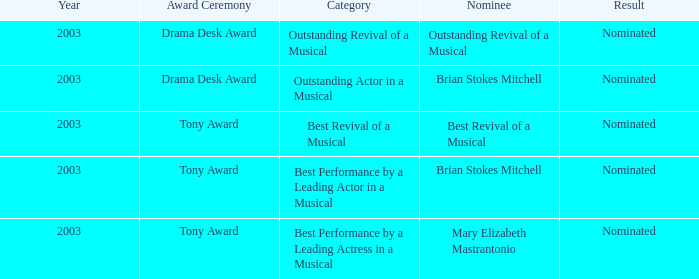What was the outcome for the best revival of a musical nomination? Nominated. 